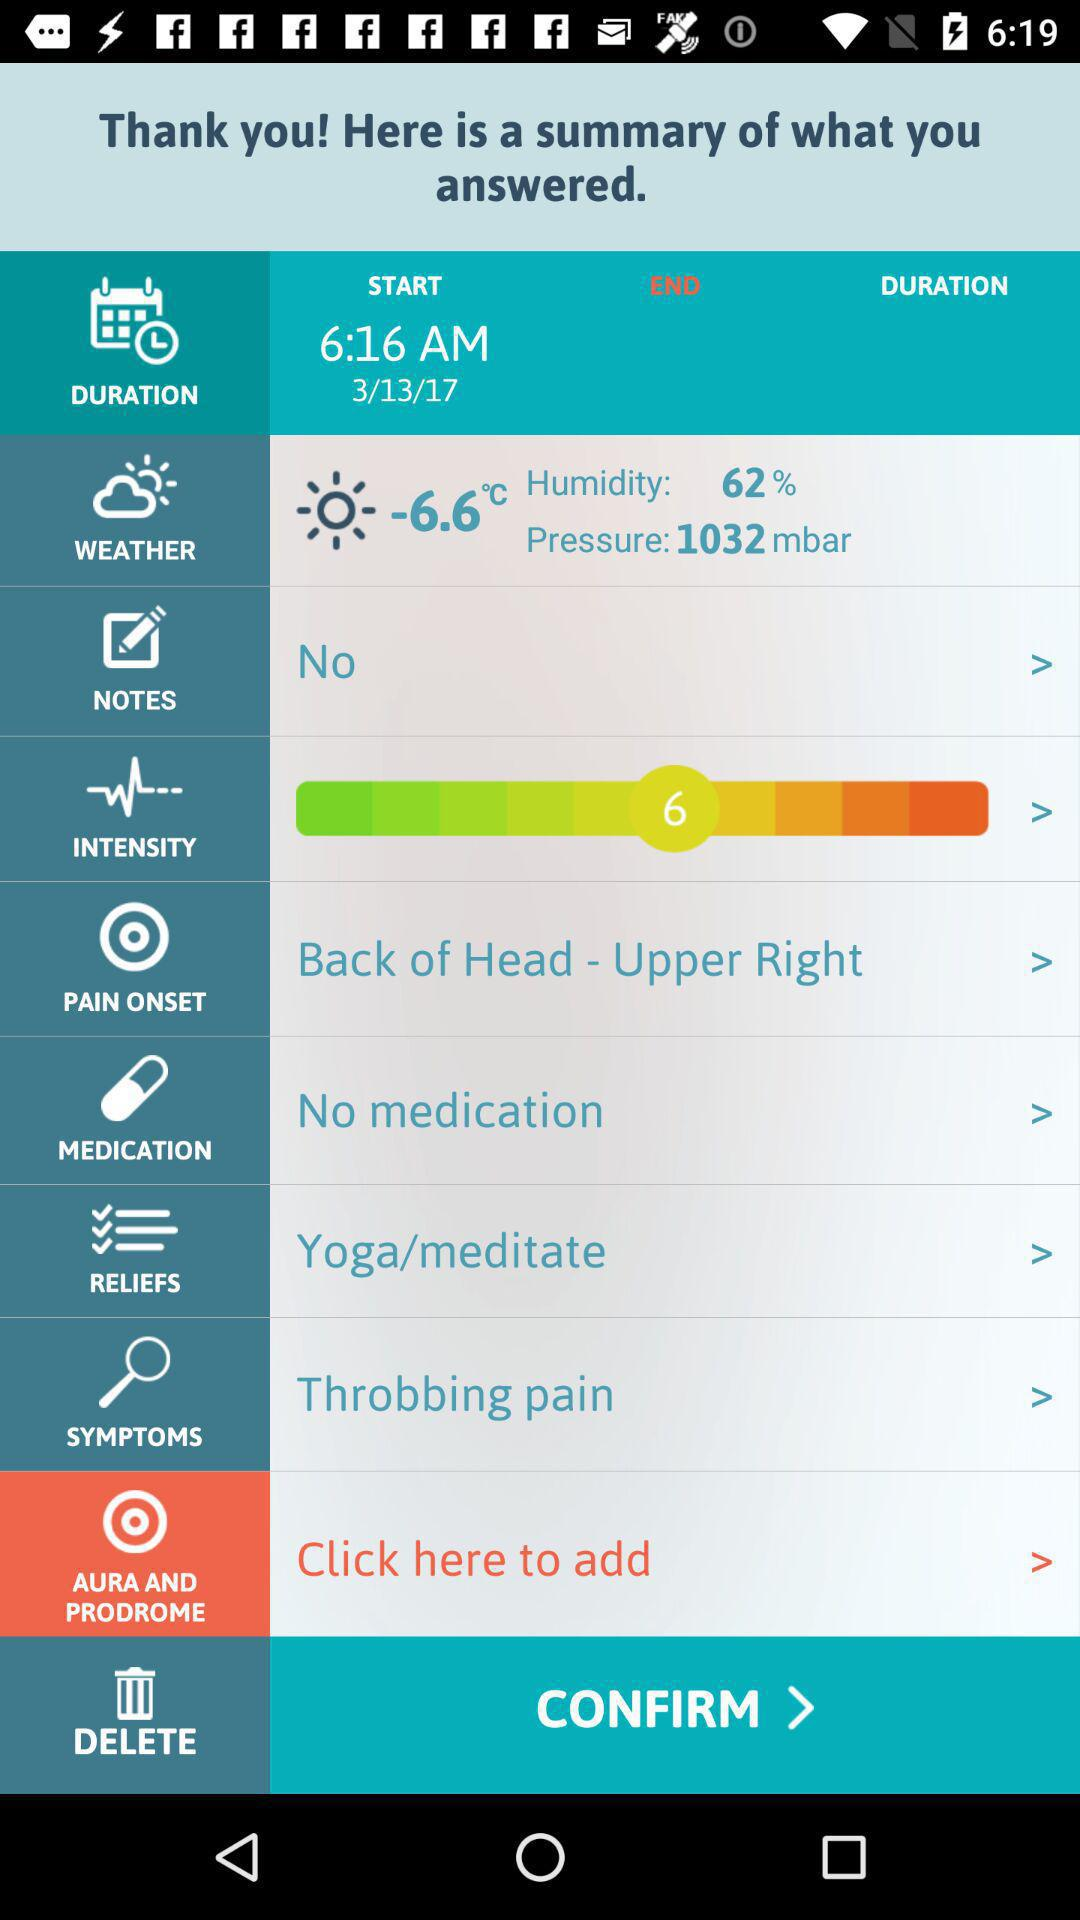Is there any medication available? There is no medication available. 